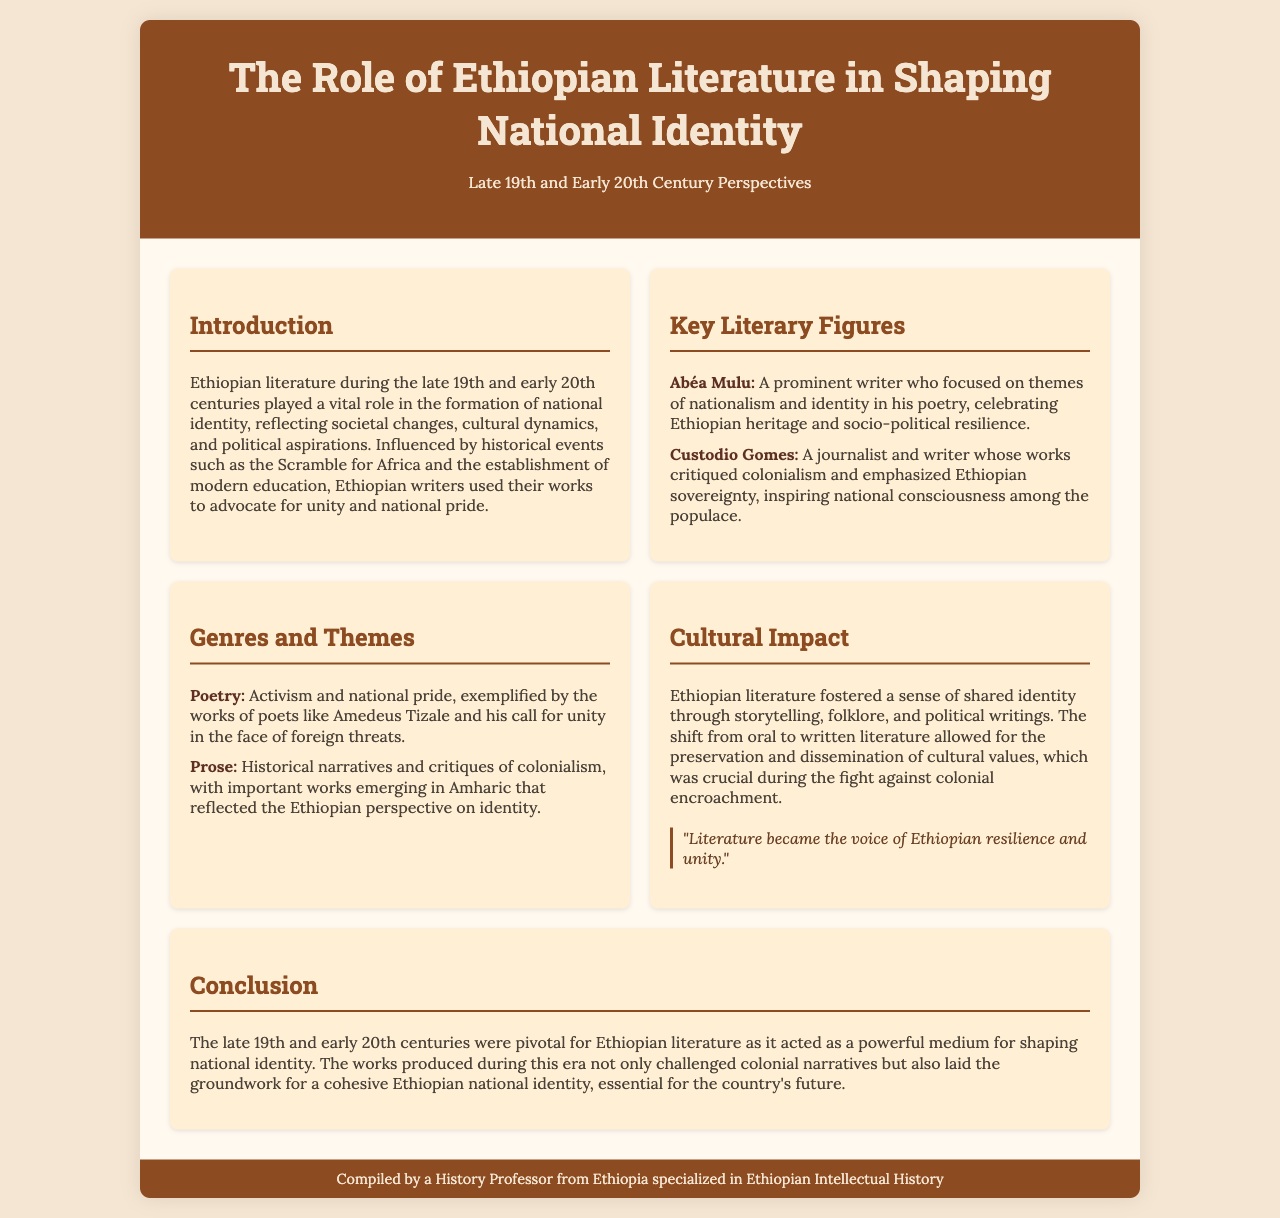What role did Ethiopian literature play in the late 19th and early 20th centuries? Ethiopian literature played a vital role in the formation of national identity, reflecting societal changes, cultural dynamics, and political aspirations.
Answer: National identity Who is a key literary figure associated with themes of nationalism? Abéa Mulu is mentioned as a prominent writer focusing on nationalism and identity in his poetry.
Answer: Abéa Mulu Which genre is emphasized for its activism and national pride? Poetry is identified as the genre exemplifying activism and national pride through works like those of Amedeus Tizale.
Answer: Poetry What significant cultural shift is noted in Ethiopian literature? The document highlights the shift from oral to written literature as a crucial cultural change.
Answer: Oral to written How did literature contribute to the fight against colonial encroachment? Literature fostered a sense of shared identity through storytelling, which was crucial during the fight against colonial encroachment.
Answer: Shared identity What was a major influence on Ethiopian writers during this period? The Scramble for Africa is cited as a significant historical event influencing Ethiopian writers.
Answer: Scramble for Africa What was the focus of Custodio Gomes’s critiques? Custodio Gomes focused on critiquing colonialism and emphasizing Ethiopian sovereignty.
Answer: Colonialism What medium did Ethiopian literature act as during the late 19th and early 20th centuries? It acted as a powerful medium for shaping national identity.
Answer: Powerful medium What type of literature reflected the Ethiopian perspective on identity? Prose reflected the Ethiopian perspective on identity through historical narratives and critiques.
Answer: Prose 